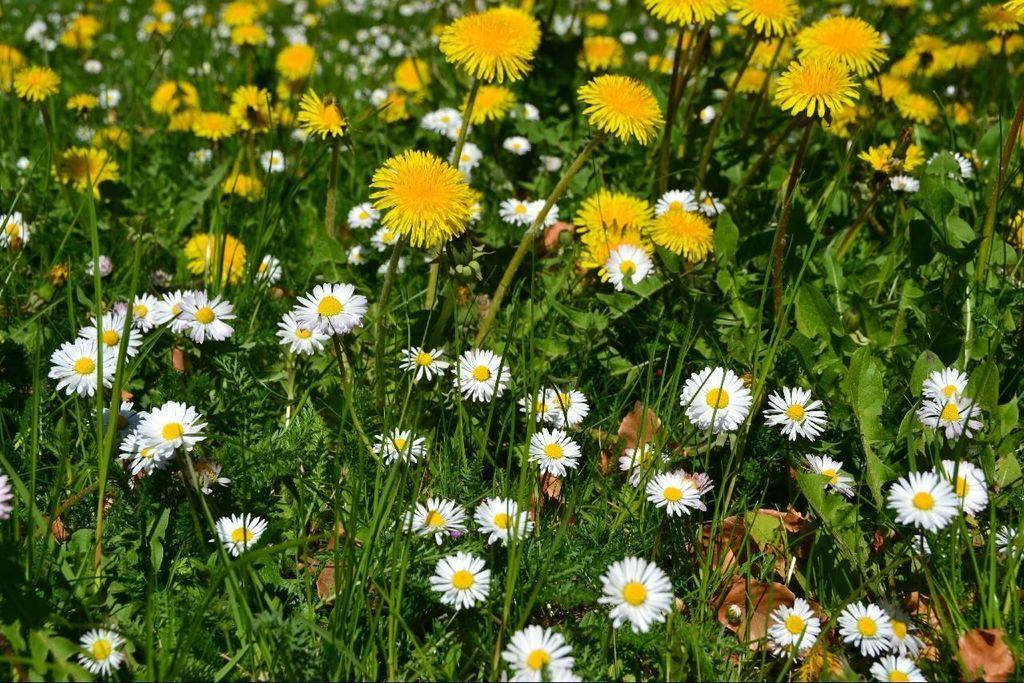What type of living organisms are in the image? There are plants in the image. What color are the flowers on the plants? The plants have yellow flowers and white flowers. How many bricks are used to build the pig pen in the image? There is no pig pen or bricks present in the image. What type of creature is seen interacting with the plants in the image? There is no creature interacting with the plants in the image; only the plants and their flowers are present. 